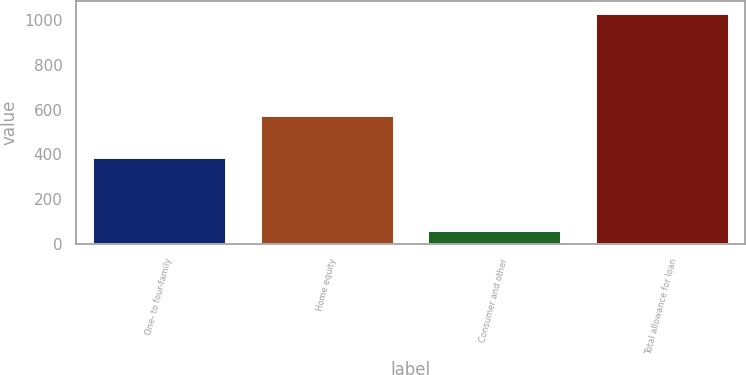Convert chart. <chart><loc_0><loc_0><loc_500><loc_500><bar_chart><fcel>One- to four-family<fcel>Home equity<fcel>Consumer and other<fcel>Total allowance for loan<nl><fcel>390<fcel>576<fcel>65<fcel>1031<nl></chart> 